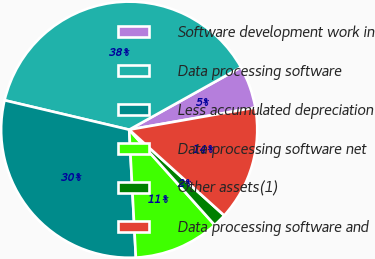Convert chart. <chart><loc_0><loc_0><loc_500><loc_500><pie_chart><fcel>Software development work in<fcel>Data processing software<fcel>Less accumulated depreciation<fcel>Data processing software net<fcel>Other assets(1)<fcel>Data processing software and<nl><fcel>5.34%<fcel>38.21%<fcel>29.52%<fcel>10.8%<fcel>1.68%<fcel>14.45%<nl></chart> 